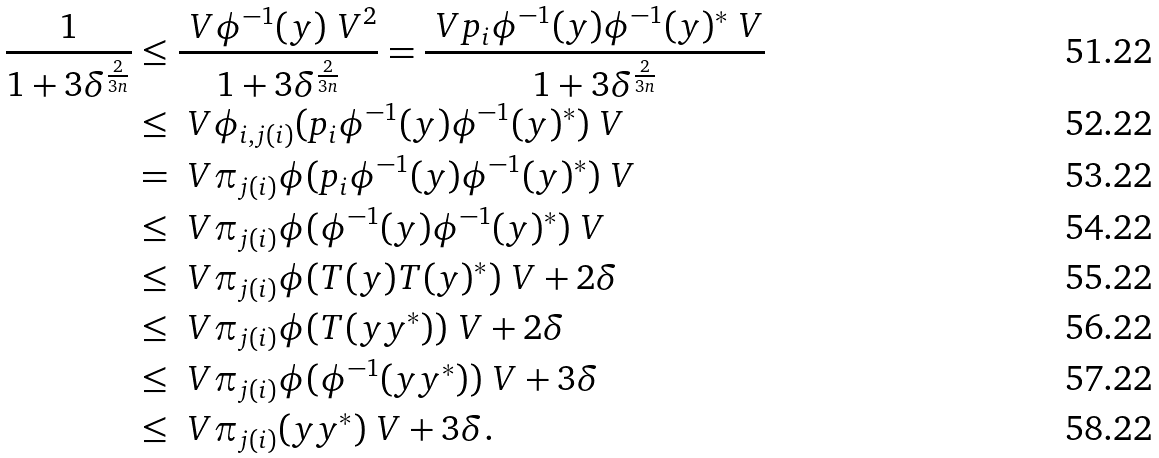Convert formula to latex. <formula><loc_0><loc_0><loc_500><loc_500>\frac { 1 } { 1 + 3 \delta ^ { \frac { 2 } { 3 n } } } & \leq \frac { \ V \phi ^ { - 1 } ( y ) \ V ^ { 2 } } { 1 + 3 \delta ^ { \frac { 2 } { 3 n } } } = \frac { \ V p _ { i } \phi ^ { - 1 } ( y ) \phi ^ { - 1 } ( y ) ^ { * } \ V } { 1 + 3 \delta ^ { \frac { 2 } { 3 n } } } \\ & \leq \ V \phi _ { i , j ( i ) } ( p _ { i } \phi ^ { - 1 } ( y ) \phi ^ { - 1 } ( y ) ^ { * } ) \ V \\ & = \ V \pi _ { j ( i ) } \phi ( p _ { i } \phi ^ { - 1 } ( y ) \phi ^ { - 1 } ( y ) ^ { * } ) \ V \\ & \leq \ V \pi _ { j ( i ) } \phi ( \phi ^ { - 1 } ( y ) \phi ^ { - 1 } ( y ) ^ { * } ) \ V \\ & \leq \ V \pi _ { j ( i ) } \phi ( T ( y ) T ( y ) ^ { * } ) \ V + 2 \delta \\ & \leq \ V \pi _ { j ( i ) } \phi ( T ( y y ^ { * } ) ) \ V + 2 \delta \\ & \leq \ V \pi _ { j ( i ) } \phi ( \phi ^ { - 1 } ( y y ^ { * } ) ) \ V + 3 \delta \\ & \leq \ V \pi _ { j ( i ) } ( y y ^ { * } ) \ V + 3 \delta .</formula> 